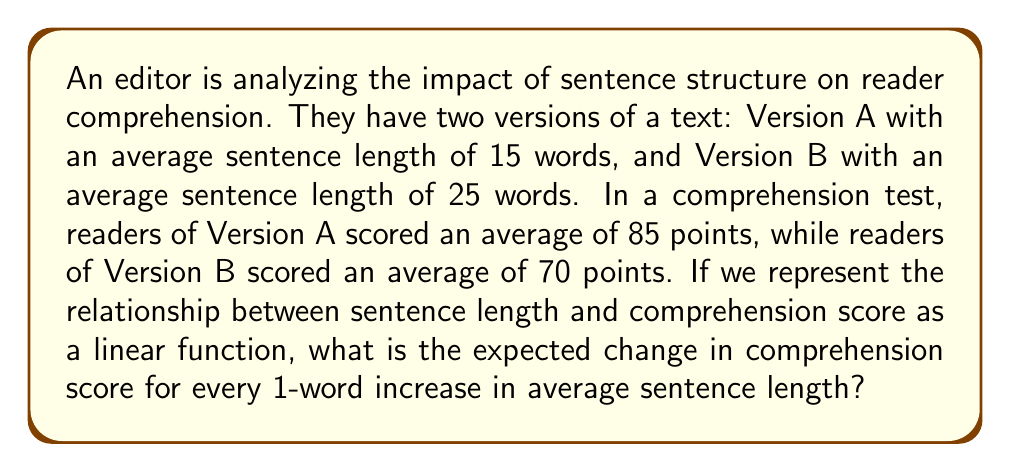Can you answer this question? To solve this problem, we can use the concept of slope in a linear function. The slope represents the rate of change between two variables.

Let's define our variables:
$x$ = average sentence length (in words)
$y$ = comprehension score

We have two data points:
$(x_1, y_1) = (15, 85)$ for Version A
$(x_2, y_2) = (25, 70)$ for Version B

The slope formula is:

$$m = \frac{y_2 - y_1}{x_2 - x_1}$$

Plugging in our values:

$$m = \frac{70 - 85}{25 - 15} = \frac{-15}{10} = -1.5$$

This means that for every 1-word increase in average sentence length, the comprehension score is expected to decrease by 1.5 points.

To verify, we can use the point-slope form of a linear equation:

$$y - y_1 = m(x - x_1)$$

Choosing $(x_1, y_1) = (15, 85)$:

$$y - 85 = -1.5(x - 15)$$

Simplifying:

$$y = -1.5x + 107.5$$

This equation accurately predicts both of our data points:

For $x = 15$: $y = -1.5(15) + 107.5 = 85$
For $x = 25$: $y = -1.5(25) + 107.5 = 70$

Therefore, the expected change in comprehension score for every 1-word increase in average sentence length is a decrease of 1.5 points.
Answer: $-1.5$ points per word 